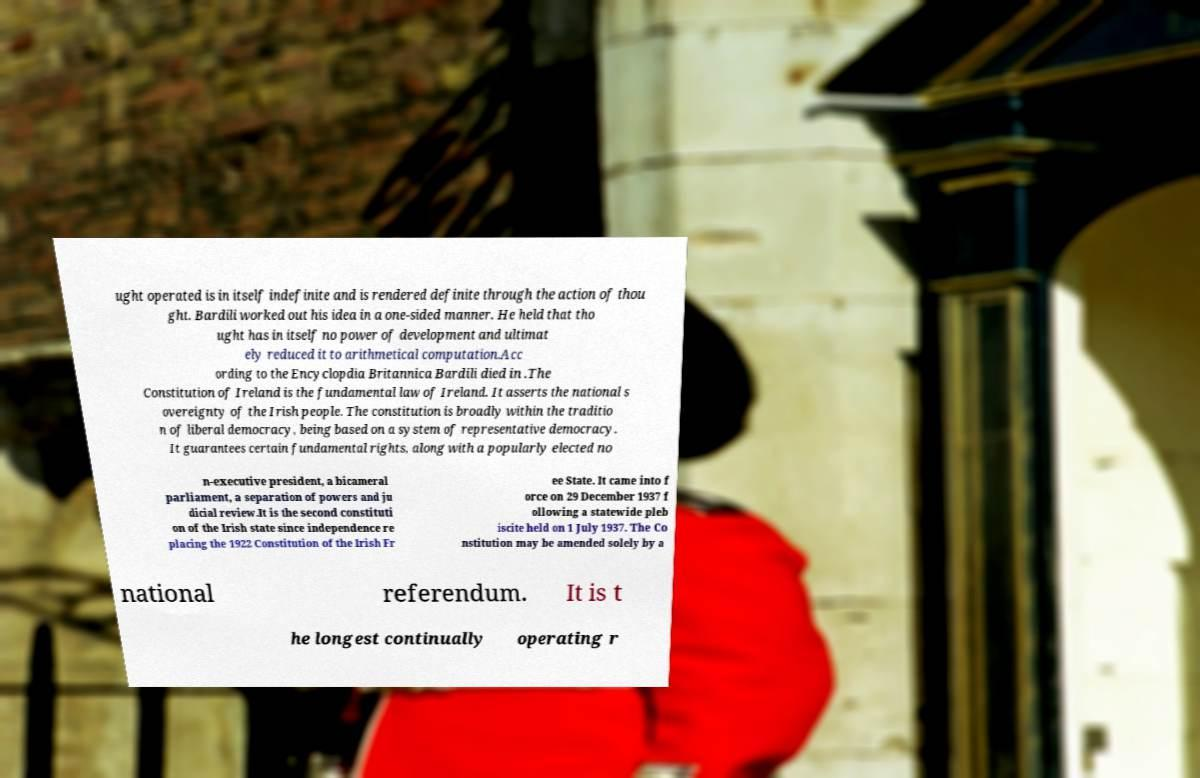Can you accurately transcribe the text from the provided image for me? ught operated is in itself indefinite and is rendered definite through the action of thou ght. Bardili worked out his idea in a one-sided manner. He held that tho ught has in itself no power of development and ultimat ely reduced it to arithmetical computation.Acc ording to the Encyclopdia Britannica Bardili died in .The Constitution of Ireland is the fundamental law of Ireland. It asserts the national s overeignty of the Irish people. The constitution is broadly within the traditio n of liberal democracy, being based on a system of representative democracy. It guarantees certain fundamental rights, along with a popularly elected no n-executive president, a bicameral parliament, a separation of powers and ju dicial review.It is the second constituti on of the Irish state since independence re placing the 1922 Constitution of the Irish Fr ee State. It came into f orce on 29 December 1937 f ollowing a statewide pleb iscite held on 1 July 1937. The Co nstitution may be amended solely by a national referendum. It is t he longest continually operating r 